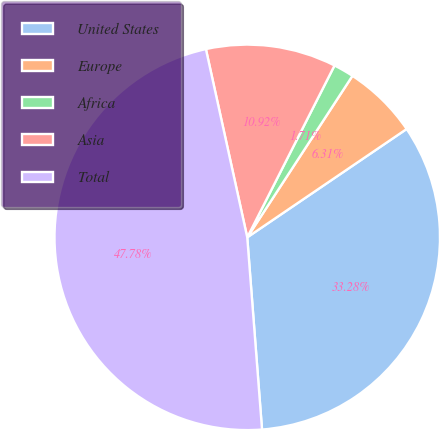Convert chart. <chart><loc_0><loc_0><loc_500><loc_500><pie_chart><fcel>United States<fcel>Europe<fcel>Africa<fcel>Asia<fcel>Total<nl><fcel>33.28%<fcel>6.31%<fcel>1.71%<fcel>10.92%<fcel>47.78%<nl></chart> 